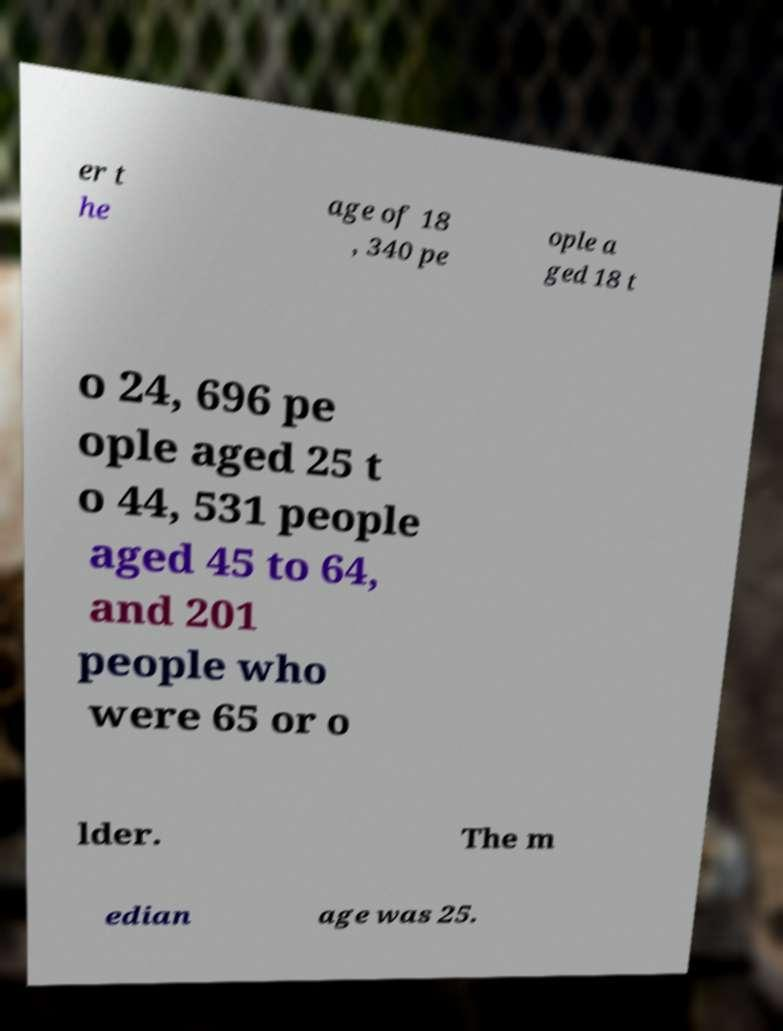Please identify and transcribe the text found in this image. er t he age of 18 , 340 pe ople a ged 18 t o 24, 696 pe ople aged 25 t o 44, 531 people aged 45 to 64, and 201 people who were 65 or o lder. The m edian age was 25. 